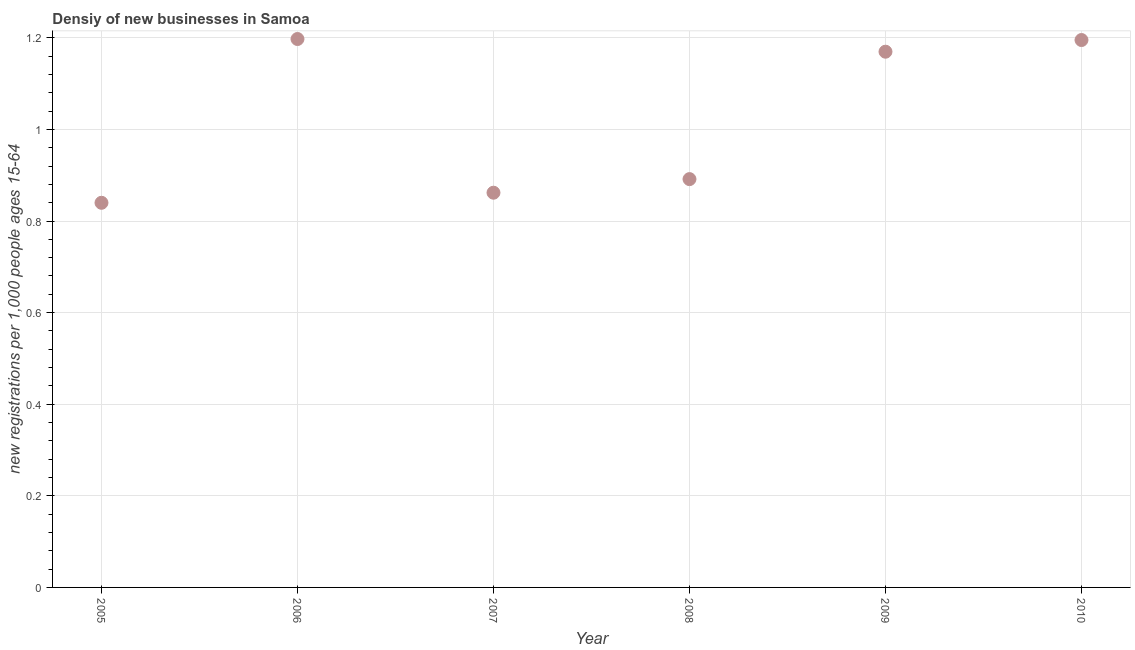What is the density of new business in 2008?
Keep it short and to the point. 0.89. Across all years, what is the maximum density of new business?
Your answer should be compact. 1.2. Across all years, what is the minimum density of new business?
Your answer should be compact. 0.84. In which year was the density of new business maximum?
Give a very brief answer. 2006. What is the sum of the density of new business?
Provide a succinct answer. 6.16. What is the difference between the density of new business in 2009 and 2010?
Provide a succinct answer. -0.03. What is the average density of new business per year?
Offer a terse response. 1.03. What is the median density of new business?
Keep it short and to the point. 1.03. In how many years, is the density of new business greater than 0.44 ?
Offer a very short reply. 6. What is the ratio of the density of new business in 2006 to that in 2009?
Keep it short and to the point. 1.02. Is the difference between the density of new business in 2006 and 2007 greater than the difference between any two years?
Your response must be concise. No. What is the difference between the highest and the second highest density of new business?
Provide a short and direct response. 0. What is the difference between the highest and the lowest density of new business?
Provide a short and direct response. 0.36. Does the density of new business monotonically increase over the years?
Offer a very short reply. No. How many dotlines are there?
Your response must be concise. 1. How many years are there in the graph?
Your answer should be compact. 6. What is the difference between two consecutive major ticks on the Y-axis?
Your answer should be compact. 0.2. Does the graph contain any zero values?
Offer a very short reply. No. What is the title of the graph?
Offer a terse response. Densiy of new businesses in Samoa. What is the label or title of the Y-axis?
Offer a very short reply. New registrations per 1,0 people ages 15-64. What is the new registrations per 1,000 people ages 15-64 in 2005?
Offer a very short reply. 0.84. What is the new registrations per 1,000 people ages 15-64 in 2006?
Ensure brevity in your answer.  1.2. What is the new registrations per 1,000 people ages 15-64 in 2007?
Your answer should be compact. 0.86. What is the new registrations per 1,000 people ages 15-64 in 2008?
Ensure brevity in your answer.  0.89. What is the new registrations per 1,000 people ages 15-64 in 2009?
Keep it short and to the point. 1.17. What is the new registrations per 1,000 people ages 15-64 in 2010?
Offer a very short reply. 1.2. What is the difference between the new registrations per 1,000 people ages 15-64 in 2005 and 2006?
Keep it short and to the point. -0.36. What is the difference between the new registrations per 1,000 people ages 15-64 in 2005 and 2007?
Keep it short and to the point. -0.02. What is the difference between the new registrations per 1,000 people ages 15-64 in 2005 and 2008?
Provide a short and direct response. -0.05. What is the difference between the new registrations per 1,000 people ages 15-64 in 2005 and 2009?
Your answer should be compact. -0.33. What is the difference between the new registrations per 1,000 people ages 15-64 in 2005 and 2010?
Provide a succinct answer. -0.36. What is the difference between the new registrations per 1,000 people ages 15-64 in 2006 and 2007?
Offer a very short reply. 0.34. What is the difference between the new registrations per 1,000 people ages 15-64 in 2006 and 2008?
Make the answer very short. 0.31. What is the difference between the new registrations per 1,000 people ages 15-64 in 2006 and 2009?
Offer a terse response. 0.03. What is the difference between the new registrations per 1,000 people ages 15-64 in 2006 and 2010?
Make the answer very short. 0. What is the difference between the new registrations per 1,000 people ages 15-64 in 2007 and 2008?
Give a very brief answer. -0.03. What is the difference between the new registrations per 1,000 people ages 15-64 in 2007 and 2009?
Offer a terse response. -0.31. What is the difference between the new registrations per 1,000 people ages 15-64 in 2007 and 2010?
Provide a succinct answer. -0.33. What is the difference between the new registrations per 1,000 people ages 15-64 in 2008 and 2009?
Your response must be concise. -0.28. What is the difference between the new registrations per 1,000 people ages 15-64 in 2008 and 2010?
Ensure brevity in your answer.  -0.3. What is the difference between the new registrations per 1,000 people ages 15-64 in 2009 and 2010?
Provide a short and direct response. -0.03. What is the ratio of the new registrations per 1,000 people ages 15-64 in 2005 to that in 2006?
Keep it short and to the point. 0.7. What is the ratio of the new registrations per 1,000 people ages 15-64 in 2005 to that in 2008?
Your answer should be very brief. 0.94. What is the ratio of the new registrations per 1,000 people ages 15-64 in 2005 to that in 2009?
Provide a short and direct response. 0.72. What is the ratio of the new registrations per 1,000 people ages 15-64 in 2005 to that in 2010?
Your answer should be very brief. 0.7. What is the ratio of the new registrations per 1,000 people ages 15-64 in 2006 to that in 2007?
Ensure brevity in your answer.  1.39. What is the ratio of the new registrations per 1,000 people ages 15-64 in 2006 to that in 2008?
Keep it short and to the point. 1.34. What is the ratio of the new registrations per 1,000 people ages 15-64 in 2007 to that in 2008?
Keep it short and to the point. 0.97. What is the ratio of the new registrations per 1,000 people ages 15-64 in 2007 to that in 2009?
Your response must be concise. 0.74. What is the ratio of the new registrations per 1,000 people ages 15-64 in 2007 to that in 2010?
Make the answer very short. 0.72. What is the ratio of the new registrations per 1,000 people ages 15-64 in 2008 to that in 2009?
Give a very brief answer. 0.76. What is the ratio of the new registrations per 1,000 people ages 15-64 in 2008 to that in 2010?
Provide a succinct answer. 0.75. 